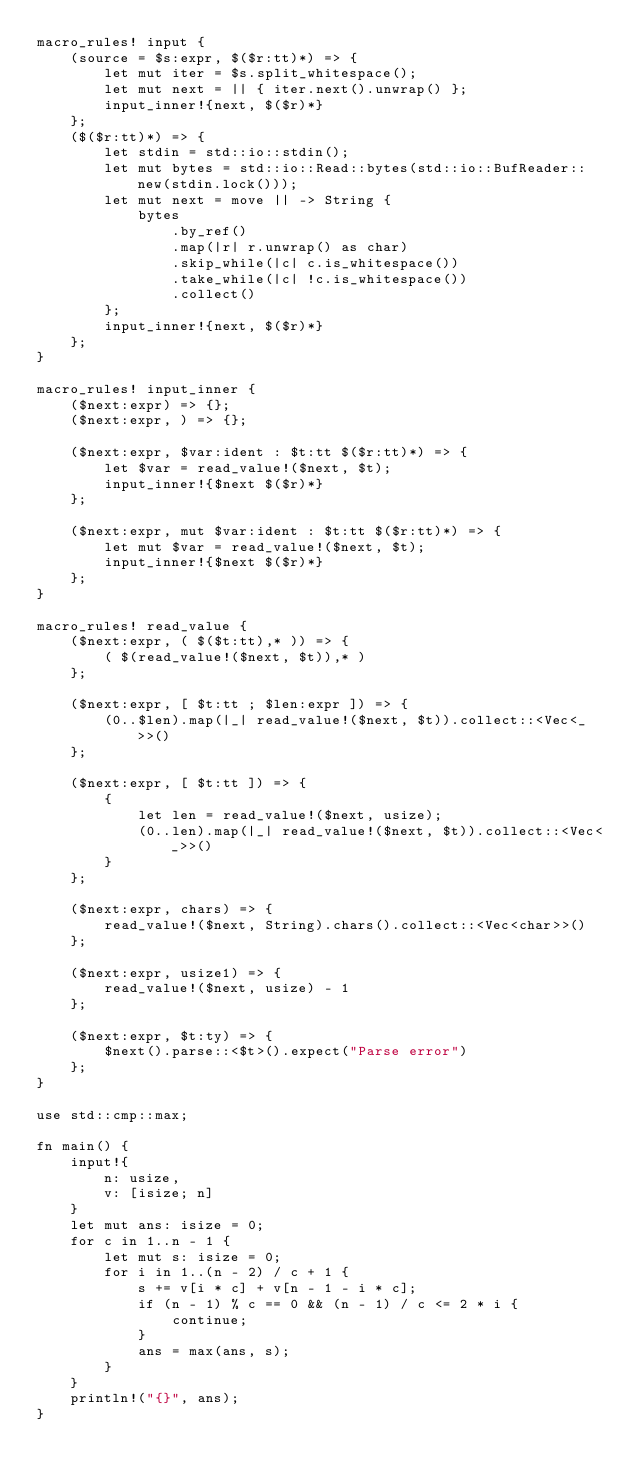<code> <loc_0><loc_0><loc_500><loc_500><_Rust_>macro_rules! input {
    (source = $s:expr, $($r:tt)*) => {
        let mut iter = $s.split_whitespace();
        let mut next = || { iter.next().unwrap() };
        input_inner!{next, $($r)*}
    };
    ($($r:tt)*) => {
        let stdin = std::io::stdin();
        let mut bytes = std::io::Read::bytes(std::io::BufReader::new(stdin.lock()));
        let mut next = move || -> String {
            bytes
                .by_ref()
                .map(|r| r.unwrap() as char)
                .skip_while(|c| c.is_whitespace())
                .take_while(|c| !c.is_whitespace())
                .collect()
        };
        input_inner!{next, $($r)*}
    };
}

macro_rules! input_inner {
    ($next:expr) => {};
    ($next:expr, ) => {};

    ($next:expr, $var:ident : $t:tt $($r:tt)*) => {
        let $var = read_value!($next, $t);
        input_inner!{$next $($r)*}
    };

    ($next:expr, mut $var:ident : $t:tt $($r:tt)*) => {
        let mut $var = read_value!($next, $t);
        input_inner!{$next $($r)*}
    };
}

macro_rules! read_value {
    ($next:expr, ( $($t:tt),* )) => {
        ( $(read_value!($next, $t)),* )
    };

    ($next:expr, [ $t:tt ; $len:expr ]) => {
        (0..$len).map(|_| read_value!($next, $t)).collect::<Vec<_>>()
    };

    ($next:expr, [ $t:tt ]) => {
        {
            let len = read_value!($next, usize);
            (0..len).map(|_| read_value!($next, $t)).collect::<Vec<_>>()
        }
    };

    ($next:expr, chars) => {
        read_value!($next, String).chars().collect::<Vec<char>>()
    };

    ($next:expr, usize1) => {
        read_value!($next, usize) - 1
    };

    ($next:expr, $t:ty) => {
        $next().parse::<$t>().expect("Parse error")
    };
}

use std::cmp::max;

fn main() {
    input!{
        n: usize,
        v: [isize; n]
    }
    let mut ans: isize = 0;
    for c in 1..n - 1 {
        let mut s: isize = 0;
        for i in 1..(n - 2) / c + 1 {
            s += v[i * c] + v[n - 1 - i * c];
            if (n - 1) % c == 0 && (n - 1) / c <= 2 * i {
                continue;
            }
            ans = max(ans, s);
        }
    }
    println!("{}", ans);
}
</code> 